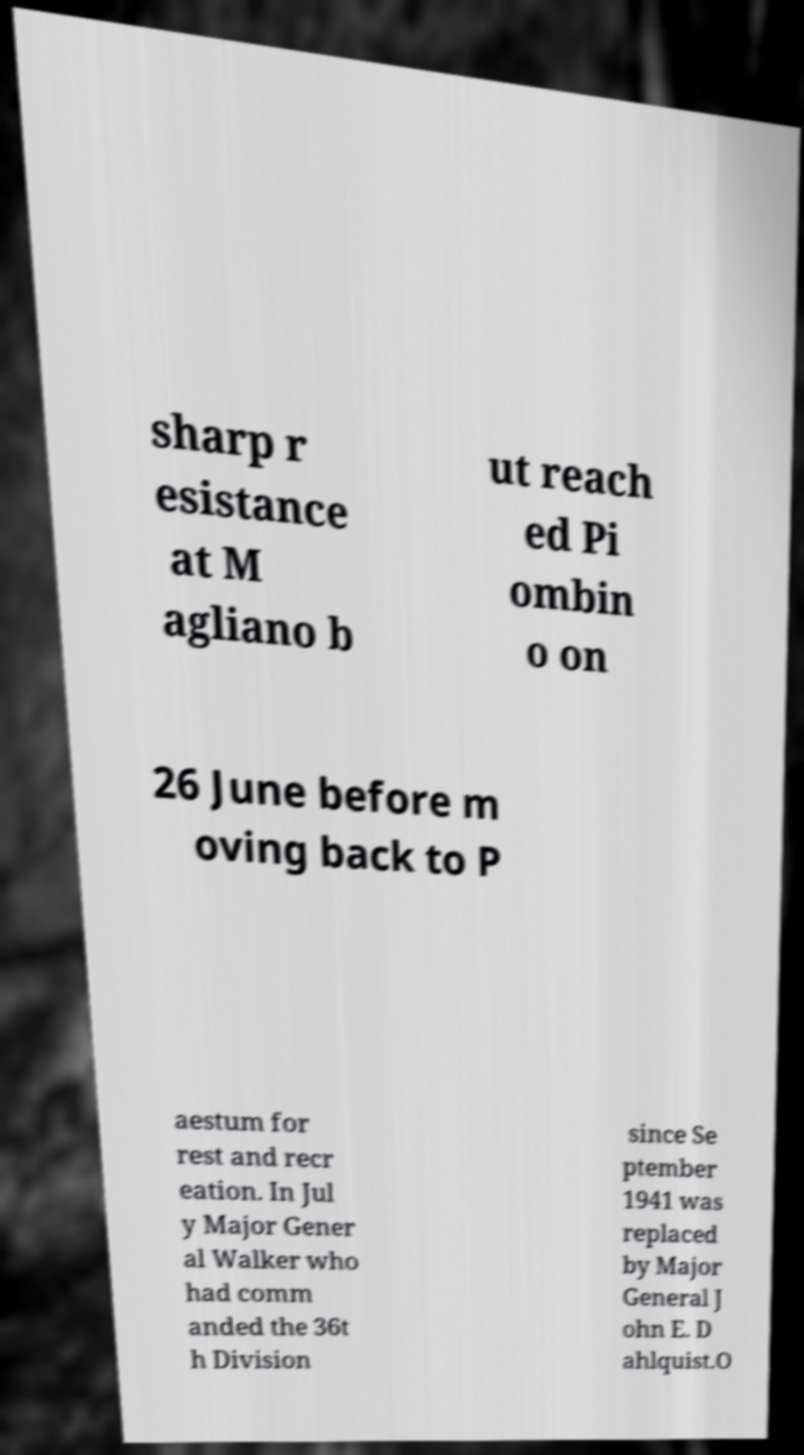Could you assist in decoding the text presented in this image and type it out clearly? sharp r esistance at M agliano b ut reach ed Pi ombin o on 26 June before m oving back to P aestum for rest and recr eation. In Jul y Major Gener al Walker who had comm anded the 36t h Division since Se ptember 1941 was replaced by Major General J ohn E. D ahlquist.O 